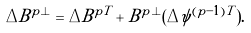Convert formula to latex. <formula><loc_0><loc_0><loc_500><loc_500>\Delta B ^ { p \perp } = \Delta B ^ { p T } + B ^ { p \perp } ( \Delta \psi ^ { ( p - 1 ) T } ) .</formula> 